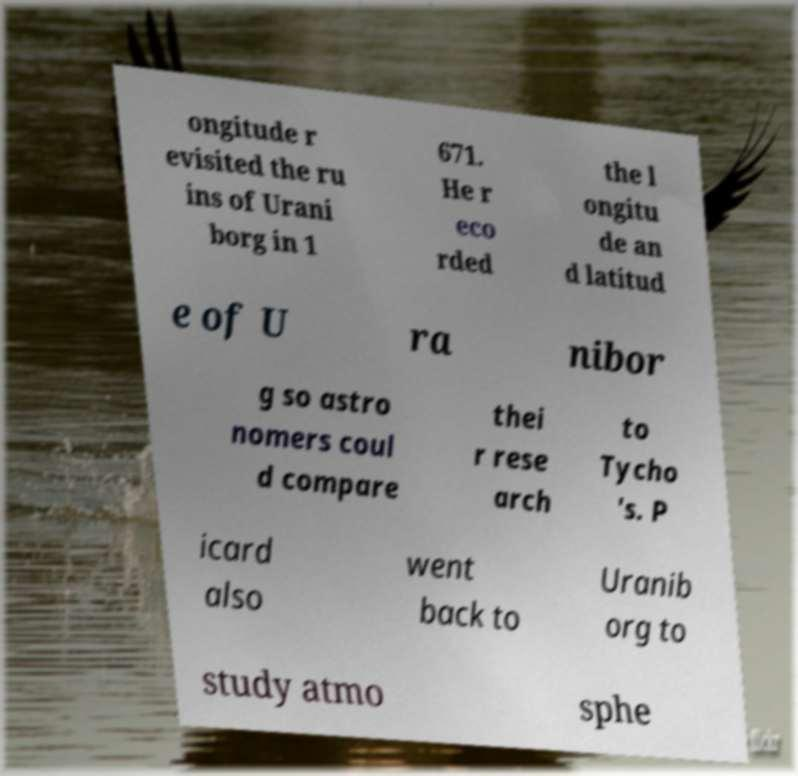Can you accurately transcribe the text from the provided image for me? ongitude r evisited the ru ins of Urani borg in 1 671. He r eco rded the l ongitu de an d latitud e of U ra nibor g so astro nomers coul d compare thei r rese arch to Tycho 's. P icard also went back to Uranib org to study atmo sphe 